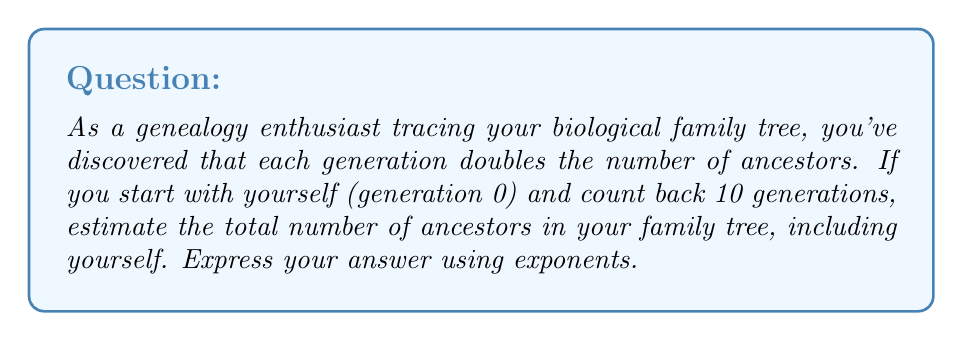What is the answer to this math problem? Let's approach this step-by-step:

1) In generation 0 (yourself), there is 1 person: $2^0 = 1$

2) In generation 1 (parents), there are 2 people: $2^1 = 2$

3) In generation 2 (grandparents), there are 4 people: $2^2 = 4$

4) This pattern continues, with each generation having $2^n$ ancestors, where $n$ is the generation number.

5) To find the total number of ancestors, we need to sum all generations from 0 to 10:

   $$ \text{Total} = 2^0 + 2^1 + 2^2 + 2^3 + ... + 2^{10} $$

6) This is a geometric series with first term $a = 1$ and common ratio $r = 2$

7) The sum of a geometric series is given by the formula:
   $$ S_n = \frac{a(1-r^{n+1})}{1-r} $$
   where $n$ is the number of terms (11 in this case, as we're counting from 0 to 10)

8) Plugging in our values:
   $$ S_{11} = \frac{1(1-2^{11})}{1-2} = \frac{1-2048}{-1} = 2047 $$

Therefore, the total number of ancestors in your family tree, including yourself, can be expressed as $2^{11} - 1$.
Answer: $2^{11} - 1$ or 2047 ancestors 